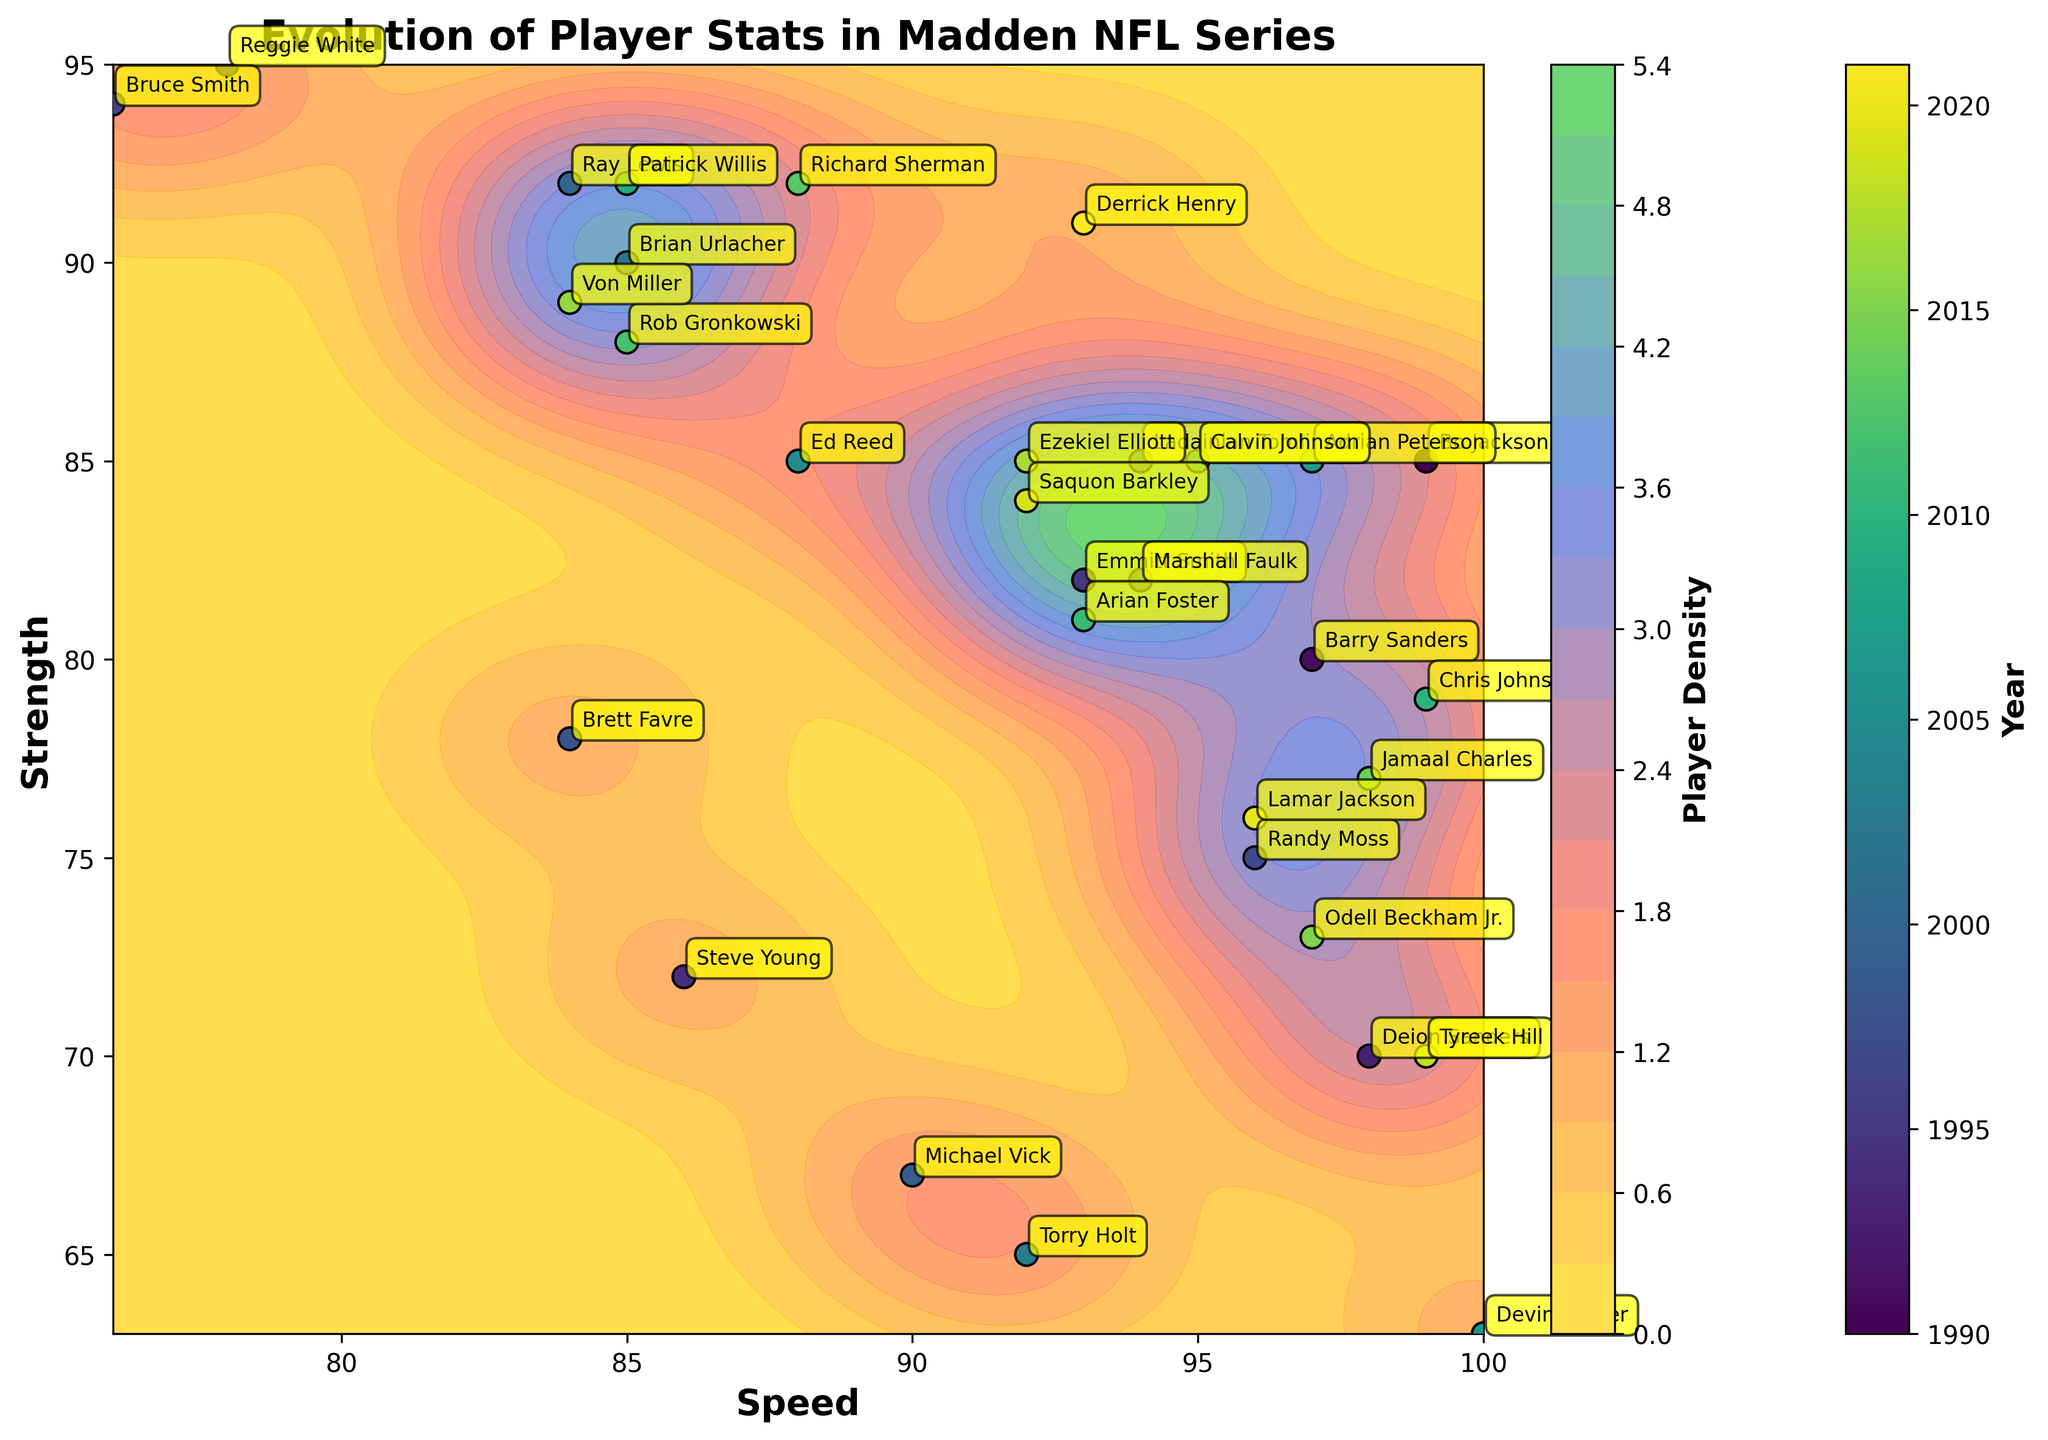How many data points are plotted in the figure? By looking at the number of labels (player names), we can count that there are 32 data points.
Answer: 32 What are the axes labels in the figure? The x-axis is labeled "Speed" and the y-axis is labeled "Strength".
Answer: Speed, Strength Which player in 2006 has the highest speed? Find the player label for the year 2006, which is Devin Hester, and note his speed value from his label.
Answer: Devin Hester Which player has the highest strength value in the plot? By checking the data, Reggie White has the highest strength value at 95.
Answer: Reggie White What is the average speed of the players from 1990 to 2000? Sum the speed values from 1990 to 2000 and divide by the number of players (10 players). The sum is \(99 + 97 + 78 + 98 + 86 + 93 + 76 + 96 + 84 + 90 = 897\). The average is \(897/10 = 89.7\).
Answer: 89.7 Who has a combined higher score of speed and strength, Bo Jackson (1990) or Derrick Henry (2021)? Bo Jackson's combined score is \(99 + 85 = 184\). Derrick Henry's combined score is \(93 + 91 = 184\). They have the same combined score.
Answer: Same Describe the trend between the speed and strength of the players over the years 1990 to 2021. Initially, the players show a high speed and variable strength. As years progress, the distribution becomes more balanced with both high and low values for speed and strength. This indicates a more diverse range of player attributes in later years.
Answer: More balanced distribution over time Which year shows a player with maximum density in the contour plot? The contour plot's highest density area can be found at the peak, considering a high density might be around average values. Check closely for the most frequent values around speed and strength junction.
Answer: Check "highest peak" Who has a more balanced speed and strength between 2012 and 2020? Compare Richard Sherman (2013) and Lamar Jackson (2020). Richard Sherman: Speed 88, Strength 92 (balanced). Lamar Jackson: Speed 96, Strength 76 (less balanced).
Answer: Richard Sherman What can you infer about player performance evolution from the contour density and year color gradient? The plot shows varying player attributes with high densities indicating common attribute values, and the gradient shows the evolution. Initially, high speeds with varied strengths, later years show more common attributes indicating adaptation to game standards.
Answer: Varying attributes, adaptation 